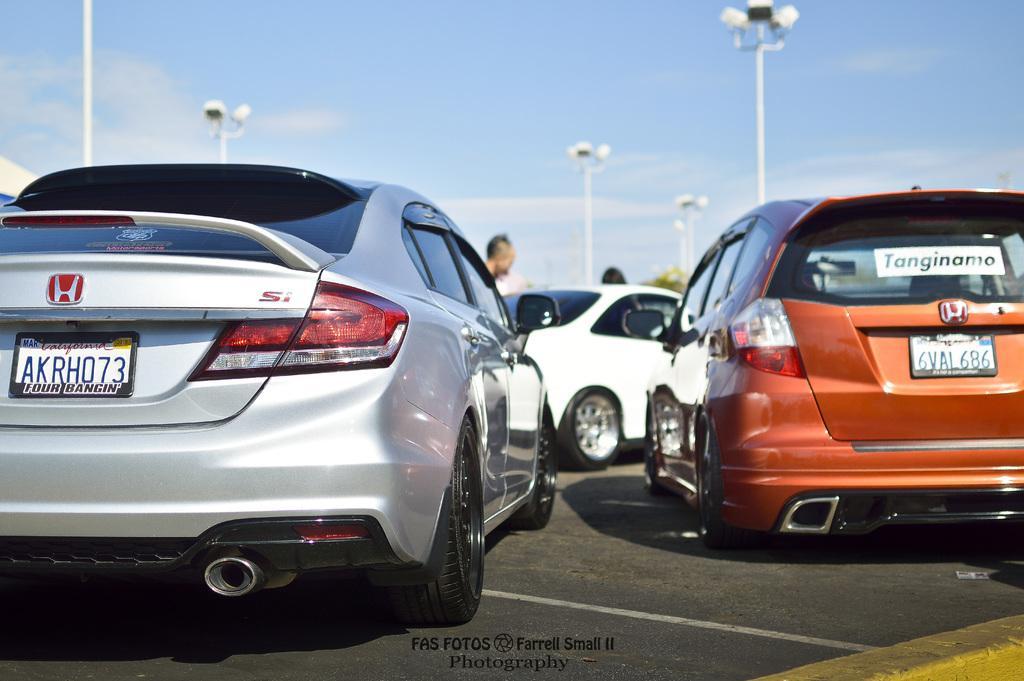Please provide a concise description of this image. In the image we can see there are many vehicles of different colors. Here we can see the number plate of the vehicle and there are even people wearing clothes. There are even light poles and the sky. On the bottom middle we can see the watermark. 